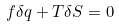Convert formula to latex. <formula><loc_0><loc_0><loc_500><loc_500>f \delta q + T \delta S = 0</formula> 